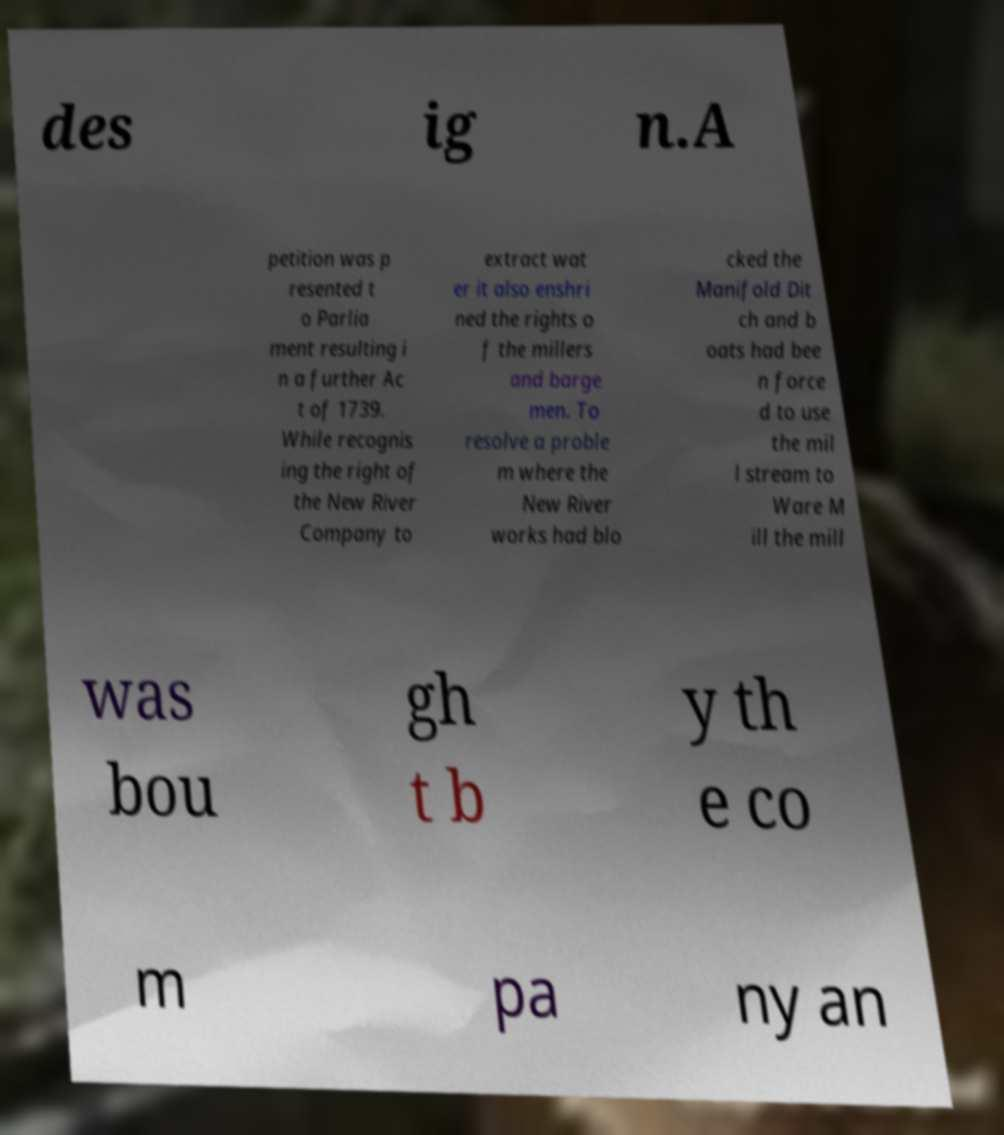I need the written content from this picture converted into text. Can you do that? des ig n.A petition was p resented t o Parlia ment resulting i n a further Ac t of 1739. While recognis ing the right of the New River Company to extract wat er it also enshri ned the rights o f the millers and barge men. To resolve a proble m where the New River works had blo cked the Manifold Dit ch and b oats had bee n force d to use the mil l stream to Ware M ill the mill was bou gh t b y th e co m pa ny an 